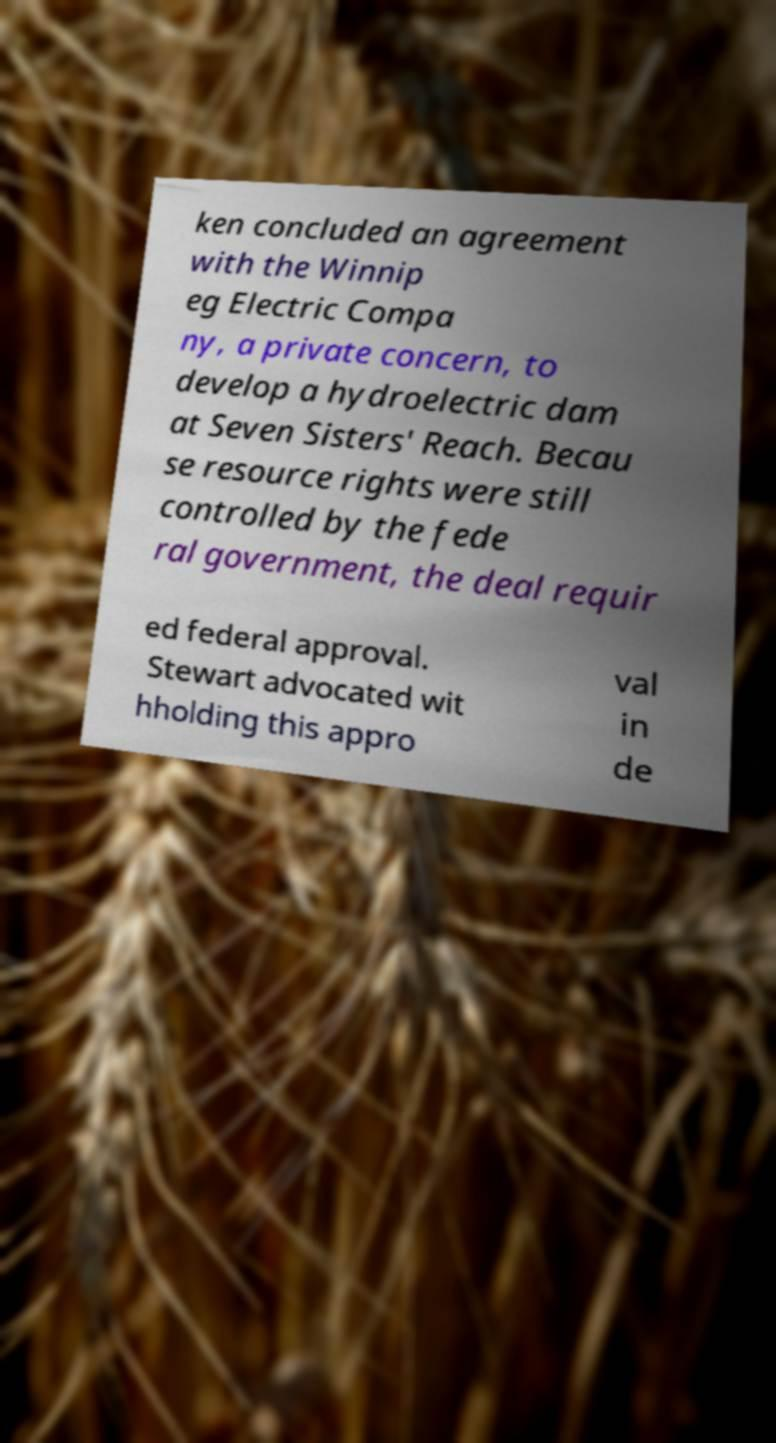Please identify and transcribe the text found in this image. ken concluded an agreement with the Winnip eg Electric Compa ny, a private concern, to develop a hydroelectric dam at Seven Sisters' Reach. Becau se resource rights were still controlled by the fede ral government, the deal requir ed federal approval. Stewart advocated wit hholding this appro val in de 